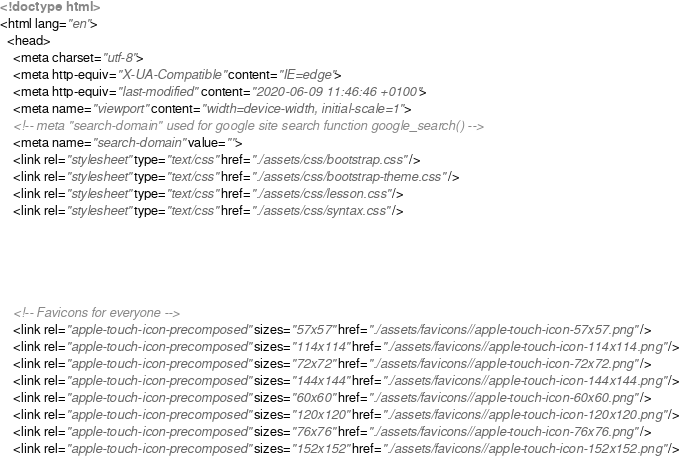Convert code to text. <code><loc_0><loc_0><loc_500><loc_500><_HTML_>















<!doctype html>
<html lang="en">
  <head>
    <meta charset="utf-8">
    <meta http-equiv="X-UA-Compatible" content="IE=edge">
    <meta http-equiv="last-modified" content="2020-06-09 11:46:46 +0100">
    <meta name="viewport" content="width=device-width, initial-scale=1">
    <!-- meta "search-domain" used for google site search function google_search() -->
    <meta name="search-domain" value="">
    <link rel="stylesheet" type="text/css" href="./assets/css/bootstrap.css" />
    <link rel="stylesheet" type="text/css" href="./assets/css/bootstrap-theme.css" />
    <link rel="stylesheet" type="text/css" href="./assets/css/lesson.css" />
    <link rel="stylesheet" type="text/css" href="./assets/css/syntax.css" />

    



    <!-- Favicons for everyone -->
    <link rel="apple-touch-icon-precomposed" sizes="57x57" href="./assets/favicons//apple-touch-icon-57x57.png" />
    <link rel="apple-touch-icon-precomposed" sizes="114x114" href="./assets/favicons//apple-touch-icon-114x114.png" />
    <link rel="apple-touch-icon-precomposed" sizes="72x72" href="./assets/favicons//apple-touch-icon-72x72.png" />
    <link rel="apple-touch-icon-precomposed" sizes="144x144" href="./assets/favicons//apple-touch-icon-144x144.png" />
    <link rel="apple-touch-icon-precomposed" sizes="60x60" href="./assets/favicons//apple-touch-icon-60x60.png" />
    <link rel="apple-touch-icon-precomposed" sizes="120x120" href="./assets/favicons//apple-touch-icon-120x120.png" />
    <link rel="apple-touch-icon-precomposed" sizes="76x76" href="./assets/favicons//apple-touch-icon-76x76.png" />
    <link rel="apple-touch-icon-precomposed" sizes="152x152" href="./assets/favicons//apple-touch-icon-152x152.png" /></code> 